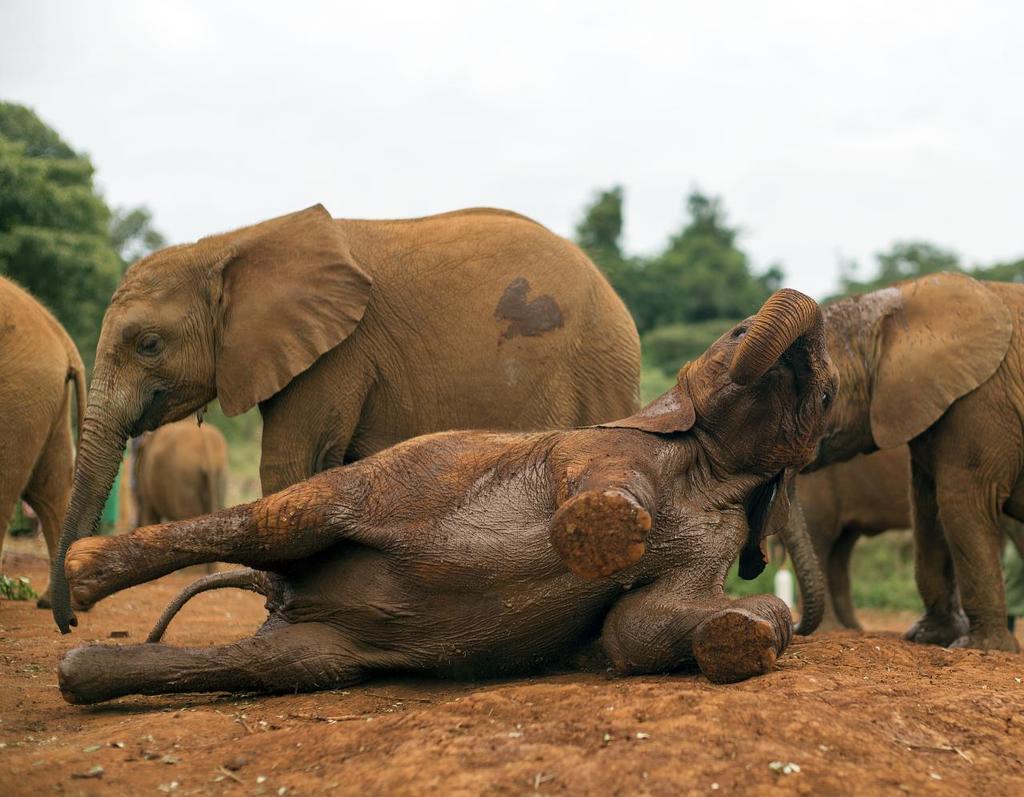Can you describe this image briefly? In this image we can see few elephants. In the foreground we can see an elephant lying on the ground. Behind the elephants we can see a group of trees. At the top we can see the sky. 